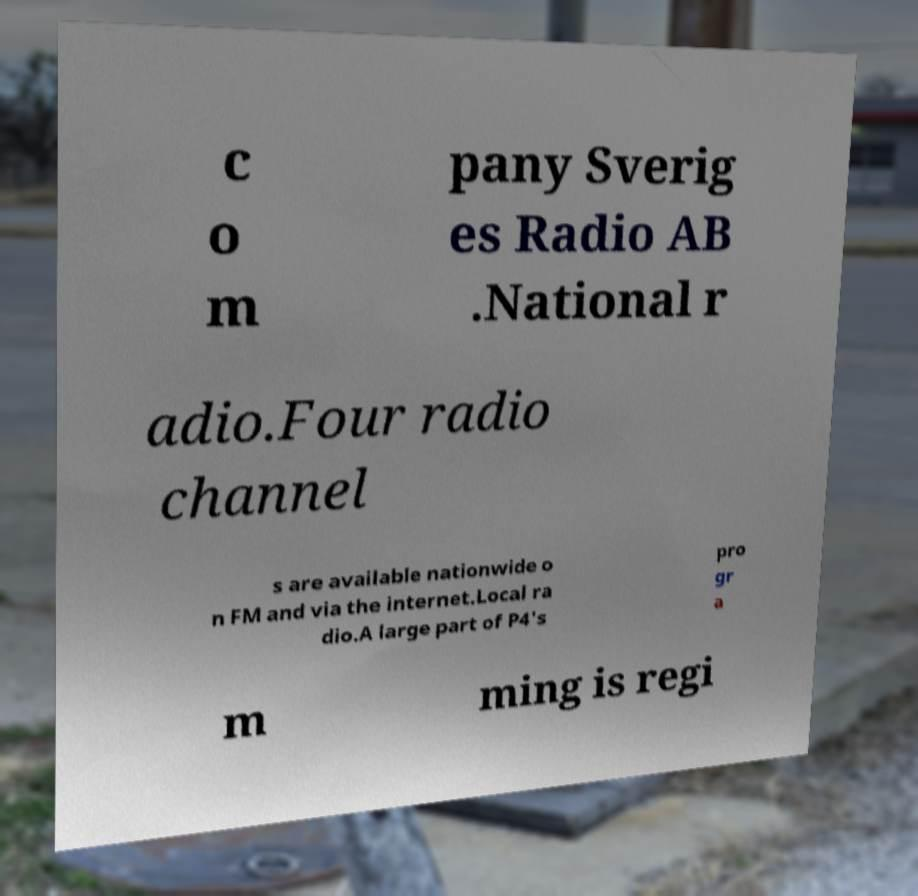Could you assist in decoding the text presented in this image and type it out clearly? c o m pany Sverig es Radio AB .National r adio.Four radio channel s are available nationwide o n FM and via the internet.Local ra dio.A large part of P4's pro gr a m ming is regi 